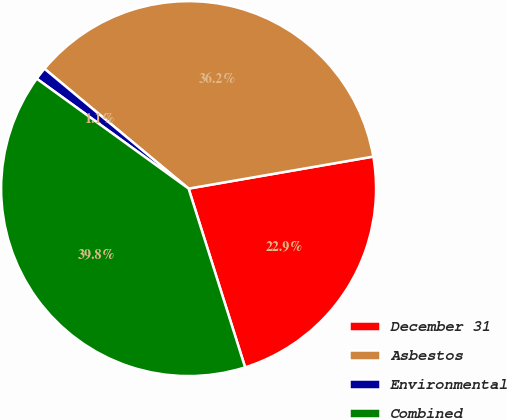Convert chart. <chart><loc_0><loc_0><loc_500><loc_500><pie_chart><fcel>December 31<fcel>Asbestos<fcel>Environmental<fcel>Combined<nl><fcel>22.86%<fcel>36.23%<fcel>1.07%<fcel>39.85%<nl></chart> 